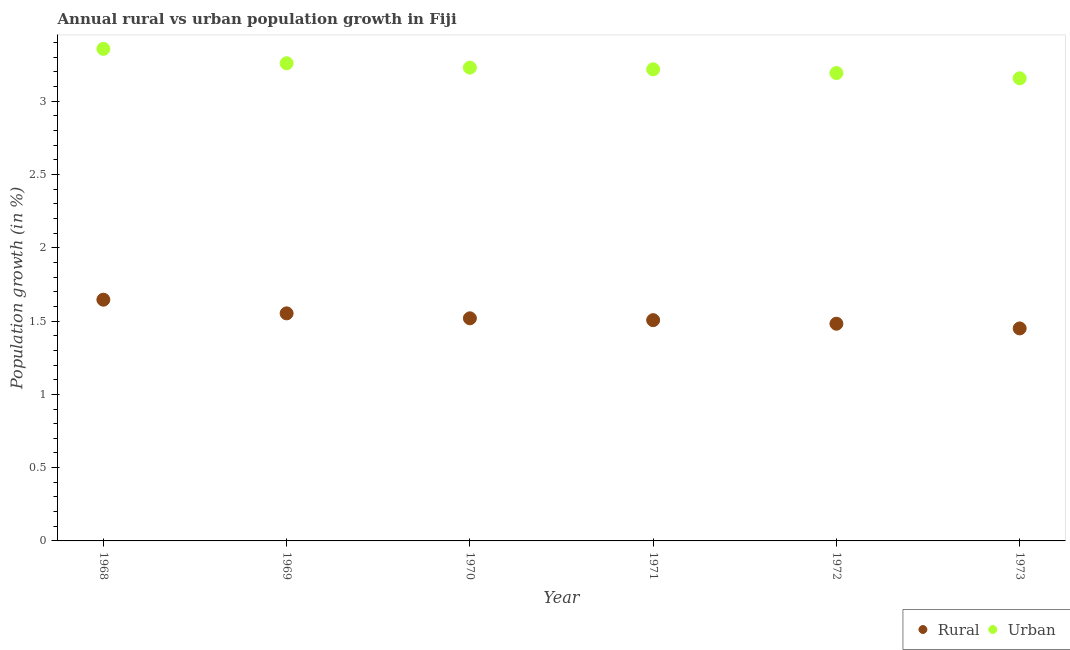How many different coloured dotlines are there?
Your answer should be compact. 2. What is the urban population growth in 1971?
Keep it short and to the point. 3.22. Across all years, what is the maximum rural population growth?
Keep it short and to the point. 1.65. Across all years, what is the minimum rural population growth?
Keep it short and to the point. 1.45. In which year was the urban population growth maximum?
Offer a very short reply. 1968. In which year was the urban population growth minimum?
Offer a terse response. 1973. What is the total urban population growth in the graph?
Keep it short and to the point. 19.42. What is the difference between the urban population growth in 1969 and that in 1972?
Offer a very short reply. 0.07. What is the difference between the urban population growth in 1968 and the rural population growth in 1970?
Your answer should be very brief. 1.84. What is the average rural population growth per year?
Offer a terse response. 1.53. In the year 1973, what is the difference between the rural population growth and urban population growth?
Offer a terse response. -1.71. What is the ratio of the rural population growth in 1972 to that in 1973?
Keep it short and to the point. 1.02. Is the difference between the urban population growth in 1968 and 1972 greater than the difference between the rural population growth in 1968 and 1972?
Keep it short and to the point. Yes. What is the difference between the highest and the second highest urban population growth?
Your answer should be very brief. 0.1. What is the difference between the highest and the lowest urban population growth?
Your answer should be compact. 0.2. Does the rural population growth monotonically increase over the years?
Your answer should be compact. No. Is the urban population growth strictly greater than the rural population growth over the years?
Give a very brief answer. Yes. How many dotlines are there?
Provide a short and direct response. 2. Does the graph contain any zero values?
Your answer should be very brief. No. How many legend labels are there?
Offer a very short reply. 2. How are the legend labels stacked?
Your answer should be compact. Horizontal. What is the title of the graph?
Keep it short and to the point. Annual rural vs urban population growth in Fiji. What is the label or title of the X-axis?
Offer a very short reply. Year. What is the label or title of the Y-axis?
Provide a succinct answer. Population growth (in %). What is the Population growth (in %) in Rural in 1968?
Keep it short and to the point. 1.65. What is the Population growth (in %) of Urban  in 1968?
Provide a short and direct response. 3.36. What is the Population growth (in %) in Rural in 1969?
Give a very brief answer. 1.55. What is the Population growth (in %) in Urban  in 1969?
Provide a succinct answer. 3.26. What is the Population growth (in %) in Rural in 1970?
Offer a very short reply. 1.52. What is the Population growth (in %) of Urban  in 1970?
Offer a very short reply. 3.23. What is the Population growth (in %) of Rural in 1971?
Provide a succinct answer. 1.51. What is the Population growth (in %) of Urban  in 1971?
Your response must be concise. 3.22. What is the Population growth (in %) of Rural in 1972?
Make the answer very short. 1.48. What is the Population growth (in %) of Urban  in 1972?
Your response must be concise. 3.19. What is the Population growth (in %) of Rural in 1973?
Your response must be concise. 1.45. What is the Population growth (in %) of Urban  in 1973?
Provide a succinct answer. 3.16. Across all years, what is the maximum Population growth (in %) in Rural?
Provide a short and direct response. 1.65. Across all years, what is the maximum Population growth (in %) of Urban ?
Offer a very short reply. 3.36. Across all years, what is the minimum Population growth (in %) of Rural?
Provide a short and direct response. 1.45. Across all years, what is the minimum Population growth (in %) of Urban ?
Provide a short and direct response. 3.16. What is the total Population growth (in %) of Rural in the graph?
Make the answer very short. 9.16. What is the total Population growth (in %) in Urban  in the graph?
Offer a very short reply. 19.42. What is the difference between the Population growth (in %) in Rural in 1968 and that in 1969?
Offer a very short reply. 0.09. What is the difference between the Population growth (in %) in Urban  in 1968 and that in 1969?
Make the answer very short. 0.1. What is the difference between the Population growth (in %) in Rural in 1968 and that in 1970?
Offer a terse response. 0.13. What is the difference between the Population growth (in %) in Urban  in 1968 and that in 1970?
Your response must be concise. 0.13. What is the difference between the Population growth (in %) in Rural in 1968 and that in 1971?
Give a very brief answer. 0.14. What is the difference between the Population growth (in %) of Urban  in 1968 and that in 1971?
Provide a succinct answer. 0.14. What is the difference between the Population growth (in %) of Rural in 1968 and that in 1972?
Ensure brevity in your answer.  0.16. What is the difference between the Population growth (in %) in Urban  in 1968 and that in 1972?
Ensure brevity in your answer.  0.17. What is the difference between the Population growth (in %) of Rural in 1968 and that in 1973?
Provide a succinct answer. 0.2. What is the difference between the Population growth (in %) in Urban  in 1968 and that in 1973?
Ensure brevity in your answer.  0.2. What is the difference between the Population growth (in %) of Rural in 1969 and that in 1970?
Offer a terse response. 0.03. What is the difference between the Population growth (in %) in Urban  in 1969 and that in 1970?
Offer a very short reply. 0.03. What is the difference between the Population growth (in %) of Rural in 1969 and that in 1971?
Provide a succinct answer. 0.05. What is the difference between the Population growth (in %) in Urban  in 1969 and that in 1971?
Give a very brief answer. 0.04. What is the difference between the Population growth (in %) in Rural in 1969 and that in 1972?
Ensure brevity in your answer.  0.07. What is the difference between the Population growth (in %) of Urban  in 1969 and that in 1972?
Keep it short and to the point. 0.07. What is the difference between the Population growth (in %) in Rural in 1969 and that in 1973?
Your answer should be compact. 0.1. What is the difference between the Population growth (in %) of Urban  in 1969 and that in 1973?
Offer a terse response. 0.1. What is the difference between the Population growth (in %) in Rural in 1970 and that in 1971?
Give a very brief answer. 0.01. What is the difference between the Population growth (in %) in Urban  in 1970 and that in 1971?
Your response must be concise. 0.01. What is the difference between the Population growth (in %) in Rural in 1970 and that in 1972?
Your answer should be compact. 0.04. What is the difference between the Population growth (in %) of Urban  in 1970 and that in 1972?
Offer a terse response. 0.04. What is the difference between the Population growth (in %) of Rural in 1970 and that in 1973?
Offer a very short reply. 0.07. What is the difference between the Population growth (in %) in Urban  in 1970 and that in 1973?
Offer a terse response. 0.07. What is the difference between the Population growth (in %) of Rural in 1971 and that in 1972?
Offer a terse response. 0.02. What is the difference between the Population growth (in %) in Urban  in 1971 and that in 1972?
Provide a succinct answer. 0.03. What is the difference between the Population growth (in %) in Rural in 1971 and that in 1973?
Offer a terse response. 0.06. What is the difference between the Population growth (in %) of Urban  in 1971 and that in 1973?
Your answer should be compact. 0.06. What is the difference between the Population growth (in %) in Rural in 1972 and that in 1973?
Give a very brief answer. 0.03. What is the difference between the Population growth (in %) of Urban  in 1972 and that in 1973?
Keep it short and to the point. 0.04. What is the difference between the Population growth (in %) of Rural in 1968 and the Population growth (in %) of Urban  in 1969?
Offer a very short reply. -1.61. What is the difference between the Population growth (in %) of Rural in 1968 and the Population growth (in %) of Urban  in 1970?
Your response must be concise. -1.58. What is the difference between the Population growth (in %) of Rural in 1968 and the Population growth (in %) of Urban  in 1971?
Give a very brief answer. -1.57. What is the difference between the Population growth (in %) of Rural in 1968 and the Population growth (in %) of Urban  in 1972?
Provide a succinct answer. -1.55. What is the difference between the Population growth (in %) in Rural in 1968 and the Population growth (in %) in Urban  in 1973?
Make the answer very short. -1.51. What is the difference between the Population growth (in %) of Rural in 1969 and the Population growth (in %) of Urban  in 1970?
Your answer should be very brief. -1.68. What is the difference between the Population growth (in %) of Rural in 1969 and the Population growth (in %) of Urban  in 1971?
Provide a short and direct response. -1.67. What is the difference between the Population growth (in %) in Rural in 1969 and the Population growth (in %) in Urban  in 1972?
Keep it short and to the point. -1.64. What is the difference between the Population growth (in %) of Rural in 1969 and the Population growth (in %) of Urban  in 1973?
Your answer should be very brief. -1.6. What is the difference between the Population growth (in %) of Rural in 1970 and the Population growth (in %) of Urban  in 1971?
Your response must be concise. -1.7. What is the difference between the Population growth (in %) of Rural in 1970 and the Population growth (in %) of Urban  in 1972?
Your answer should be compact. -1.67. What is the difference between the Population growth (in %) of Rural in 1970 and the Population growth (in %) of Urban  in 1973?
Give a very brief answer. -1.64. What is the difference between the Population growth (in %) in Rural in 1971 and the Population growth (in %) in Urban  in 1972?
Your answer should be very brief. -1.69. What is the difference between the Population growth (in %) in Rural in 1971 and the Population growth (in %) in Urban  in 1973?
Provide a short and direct response. -1.65. What is the difference between the Population growth (in %) in Rural in 1972 and the Population growth (in %) in Urban  in 1973?
Your response must be concise. -1.67. What is the average Population growth (in %) in Rural per year?
Ensure brevity in your answer.  1.53. What is the average Population growth (in %) of Urban  per year?
Your response must be concise. 3.24. In the year 1968, what is the difference between the Population growth (in %) of Rural and Population growth (in %) of Urban ?
Your answer should be very brief. -1.71. In the year 1969, what is the difference between the Population growth (in %) of Rural and Population growth (in %) of Urban ?
Provide a succinct answer. -1.71. In the year 1970, what is the difference between the Population growth (in %) in Rural and Population growth (in %) in Urban ?
Your answer should be compact. -1.71. In the year 1971, what is the difference between the Population growth (in %) of Rural and Population growth (in %) of Urban ?
Your response must be concise. -1.71. In the year 1972, what is the difference between the Population growth (in %) in Rural and Population growth (in %) in Urban ?
Offer a terse response. -1.71. In the year 1973, what is the difference between the Population growth (in %) in Rural and Population growth (in %) in Urban ?
Your response must be concise. -1.71. What is the ratio of the Population growth (in %) in Rural in 1968 to that in 1969?
Make the answer very short. 1.06. What is the ratio of the Population growth (in %) in Urban  in 1968 to that in 1969?
Give a very brief answer. 1.03. What is the ratio of the Population growth (in %) in Rural in 1968 to that in 1970?
Ensure brevity in your answer.  1.08. What is the ratio of the Population growth (in %) of Urban  in 1968 to that in 1970?
Your answer should be very brief. 1.04. What is the ratio of the Population growth (in %) in Rural in 1968 to that in 1971?
Offer a very short reply. 1.09. What is the ratio of the Population growth (in %) of Urban  in 1968 to that in 1971?
Make the answer very short. 1.04. What is the ratio of the Population growth (in %) in Rural in 1968 to that in 1972?
Your answer should be very brief. 1.11. What is the ratio of the Population growth (in %) of Urban  in 1968 to that in 1972?
Keep it short and to the point. 1.05. What is the ratio of the Population growth (in %) of Rural in 1968 to that in 1973?
Make the answer very short. 1.14. What is the ratio of the Population growth (in %) of Urban  in 1968 to that in 1973?
Offer a very short reply. 1.06. What is the ratio of the Population growth (in %) in Rural in 1969 to that in 1970?
Make the answer very short. 1.02. What is the ratio of the Population growth (in %) in Urban  in 1969 to that in 1970?
Your response must be concise. 1.01. What is the ratio of the Population growth (in %) of Rural in 1969 to that in 1971?
Your answer should be very brief. 1.03. What is the ratio of the Population growth (in %) in Urban  in 1969 to that in 1971?
Keep it short and to the point. 1.01. What is the ratio of the Population growth (in %) of Rural in 1969 to that in 1972?
Offer a very short reply. 1.05. What is the ratio of the Population growth (in %) of Urban  in 1969 to that in 1972?
Offer a terse response. 1.02. What is the ratio of the Population growth (in %) in Rural in 1969 to that in 1973?
Your answer should be compact. 1.07. What is the ratio of the Population growth (in %) of Urban  in 1969 to that in 1973?
Offer a very short reply. 1.03. What is the ratio of the Population growth (in %) in Rural in 1970 to that in 1971?
Keep it short and to the point. 1.01. What is the ratio of the Population growth (in %) in Rural in 1970 to that in 1972?
Provide a succinct answer. 1.02. What is the ratio of the Population growth (in %) of Urban  in 1970 to that in 1972?
Your response must be concise. 1.01. What is the ratio of the Population growth (in %) in Rural in 1970 to that in 1973?
Offer a very short reply. 1.05. What is the ratio of the Population growth (in %) of Urban  in 1970 to that in 1973?
Provide a succinct answer. 1.02. What is the ratio of the Population growth (in %) of Rural in 1971 to that in 1972?
Ensure brevity in your answer.  1.02. What is the ratio of the Population growth (in %) of Urban  in 1971 to that in 1972?
Provide a succinct answer. 1.01. What is the ratio of the Population growth (in %) in Rural in 1971 to that in 1973?
Your answer should be compact. 1.04. What is the ratio of the Population growth (in %) of Urban  in 1971 to that in 1973?
Make the answer very short. 1.02. What is the ratio of the Population growth (in %) in Rural in 1972 to that in 1973?
Make the answer very short. 1.02. What is the ratio of the Population growth (in %) of Urban  in 1972 to that in 1973?
Your answer should be very brief. 1.01. What is the difference between the highest and the second highest Population growth (in %) of Rural?
Provide a short and direct response. 0.09. What is the difference between the highest and the second highest Population growth (in %) of Urban ?
Your response must be concise. 0.1. What is the difference between the highest and the lowest Population growth (in %) of Rural?
Provide a succinct answer. 0.2. What is the difference between the highest and the lowest Population growth (in %) of Urban ?
Your answer should be very brief. 0.2. 